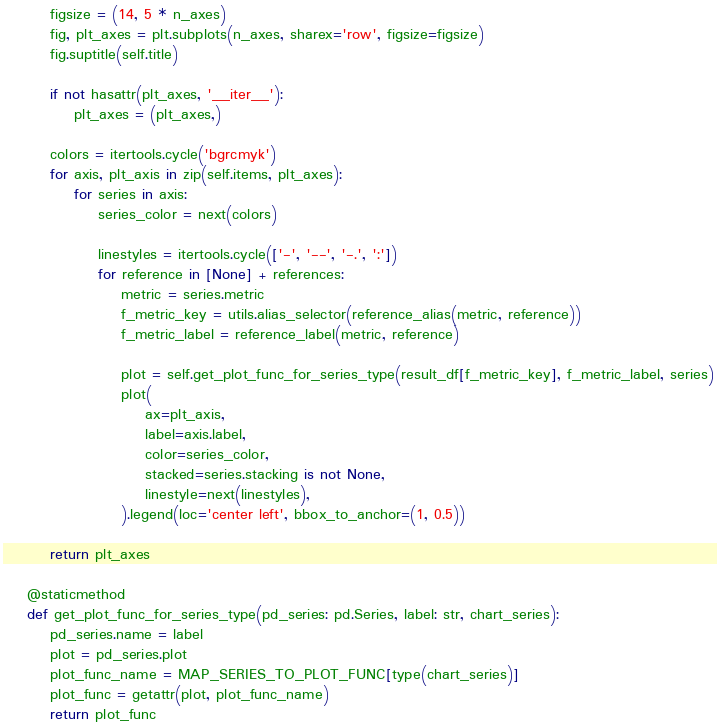Convert code to text. <code><loc_0><loc_0><loc_500><loc_500><_Python_>        figsize = (14, 5 * n_axes)
        fig, plt_axes = plt.subplots(n_axes, sharex='row', figsize=figsize)
        fig.suptitle(self.title)

        if not hasattr(plt_axes, '__iter__'):
            plt_axes = (plt_axes,)

        colors = itertools.cycle('bgrcmyk')
        for axis, plt_axis in zip(self.items, plt_axes):
            for series in axis:
                series_color = next(colors)

                linestyles = itertools.cycle(['-', '--', '-.', ':'])
                for reference in [None] + references:
                    metric = series.metric
                    f_metric_key = utils.alias_selector(reference_alias(metric, reference))
                    f_metric_label = reference_label(metric, reference)

                    plot = self.get_plot_func_for_series_type(result_df[f_metric_key], f_metric_label, series)
                    plot(
                        ax=plt_axis,
                        label=axis.label,
                        color=series_color,
                        stacked=series.stacking is not None,
                        linestyle=next(linestyles),
                    ).legend(loc='center left', bbox_to_anchor=(1, 0.5))

        return plt_axes

    @staticmethod
    def get_plot_func_for_series_type(pd_series: pd.Series, label: str, chart_series):
        pd_series.name = label
        plot = pd_series.plot
        plot_func_name = MAP_SERIES_TO_PLOT_FUNC[type(chart_series)]
        plot_func = getattr(plot, plot_func_name)
        return plot_func
</code> 